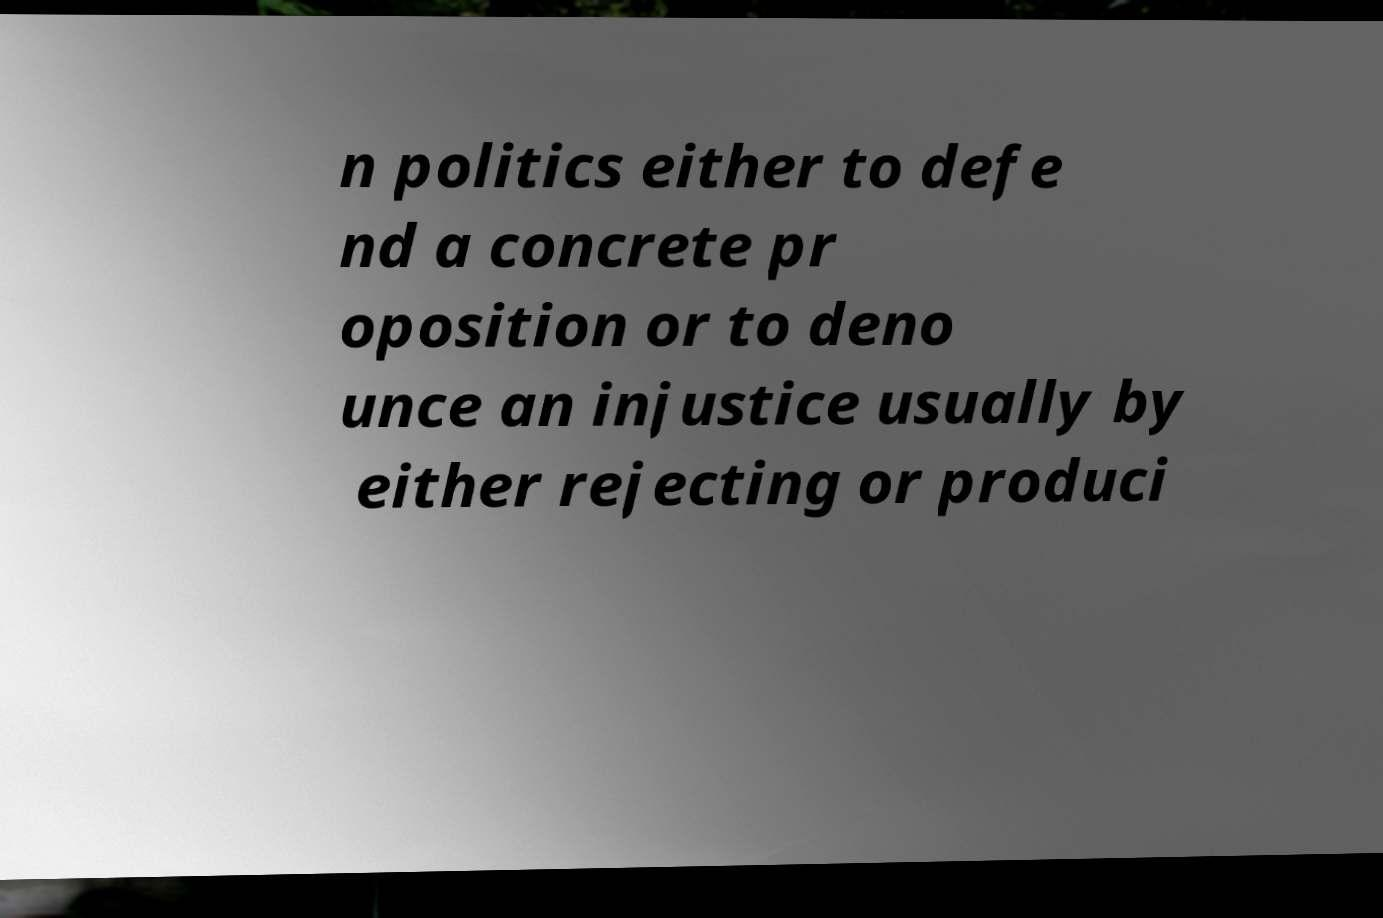What messages or text are displayed in this image? I need them in a readable, typed format. n politics either to defe nd a concrete pr oposition or to deno unce an injustice usually by either rejecting or produci 